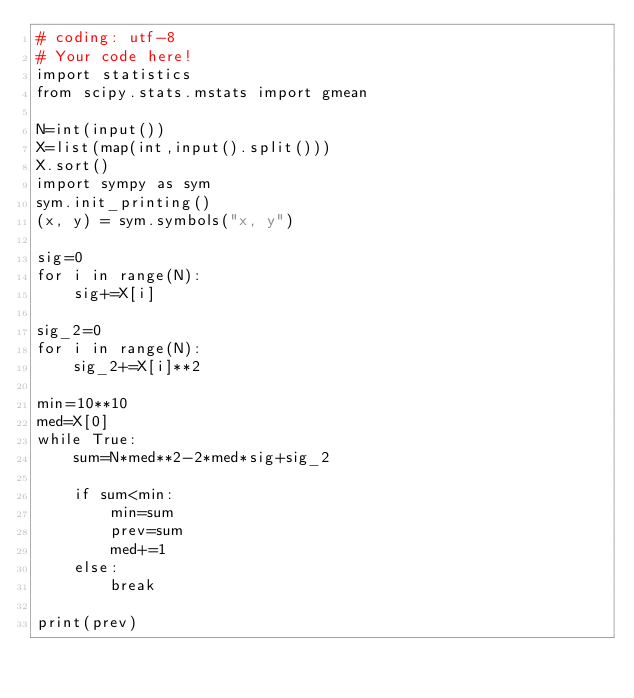<code> <loc_0><loc_0><loc_500><loc_500><_Python_># coding: utf-8
# Your code here!
import statistics
from scipy.stats.mstats import gmean

N=int(input())
X=list(map(int,input().split()))
X.sort()
import sympy as sym
sym.init_printing()
(x, y) = sym.symbols("x, y")

sig=0
for i in range(N):
    sig+=X[i]

sig_2=0
for i in range(N):
    sig_2+=X[i]**2

min=10**10
med=X[0]
while True:
    sum=N*med**2-2*med*sig+sig_2

    if sum<min:
        min=sum
        prev=sum
        med+=1
    else:
        break

print(prev)
</code> 